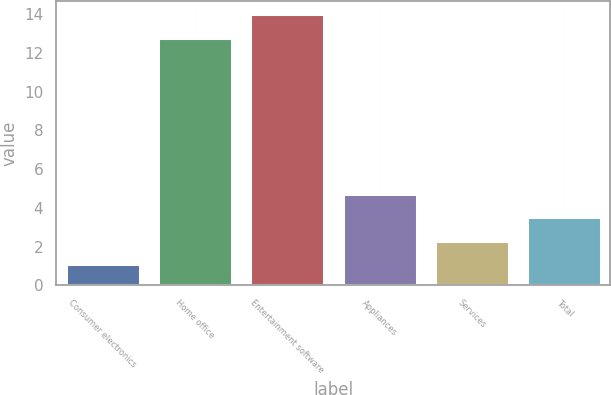<chart> <loc_0><loc_0><loc_500><loc_500><bar_chart><fcel>Consumer electronics<fcel>Home office<fcel>Entertainment software<fcel>Appliances<fcel>Services<fcel>Total<nl><fcel>1.1<fcel>12.8<fcel>14.01<fcel>4.73<fcel>2.31<fcel>3.52<nl></chart> 